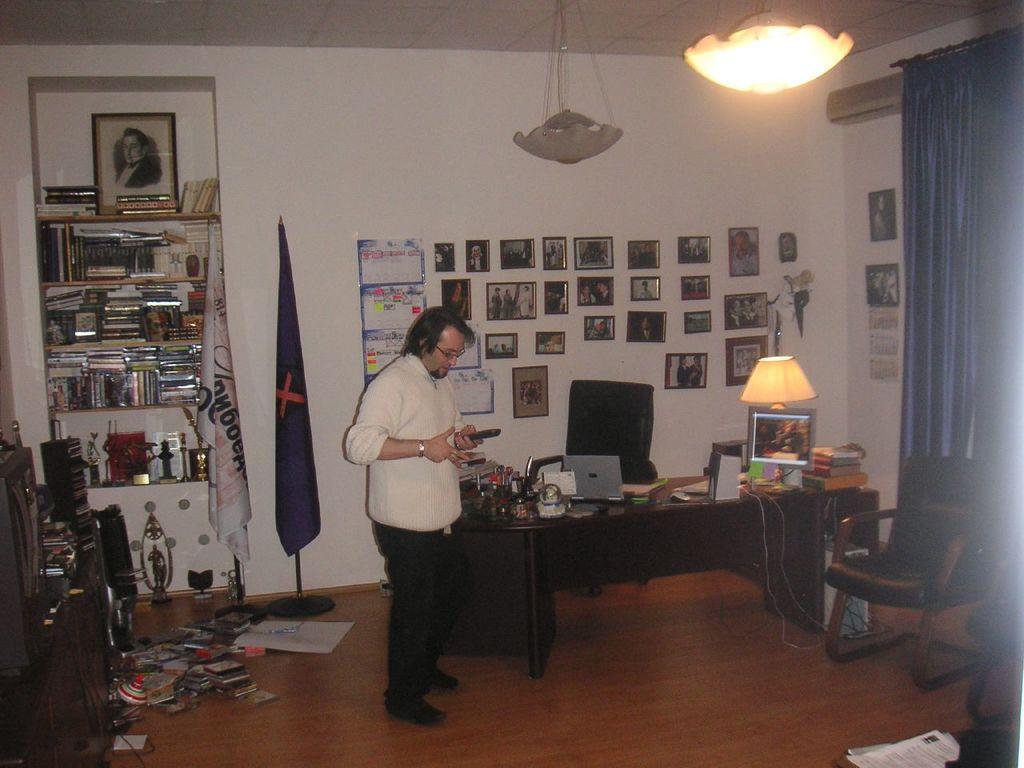In one or two sentences, can you explain what this image depicts? In this image i can see a man standing and holding remote at the back ground i can see a chair,a laptop, bottles and a frame on a table there are few frames attached to a wall there are two flags, there are few books, a frame in a rack at the top there is a light at right there is a curtain. 